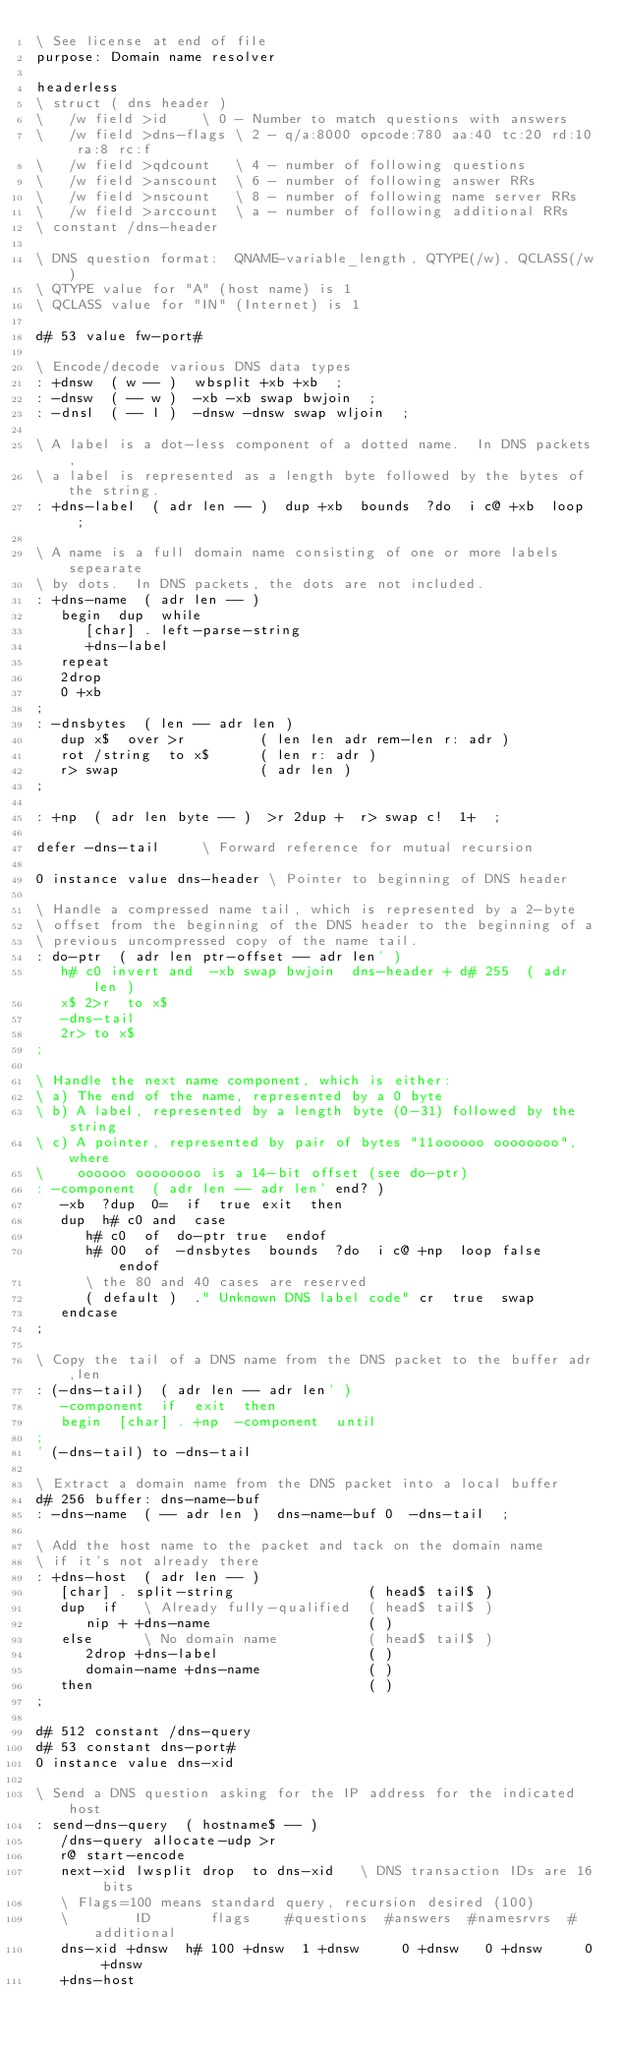Convert code to text. <code><loc_0><loc_0><loc_500><loc_500><_Forth_>\ See license at end of file
purpose: Domain name resolver

headerless
\ struct ( dns header )
\   /w field >id	\ 0 - Number to match questions with answers
\   /w field >dns-flags	\ 2 - q/a:8000 opcode:780 aa:40 tc:20 rd:10 ra:8 rc:f
\   /w field >qdcount	\ 4 - number of following questions
\   /w field >anscount	\ 6 - number of following answer RRs
\   /w field >nscount	\ 8 - number of following name server RRs
\   /w field >arccount	\ a - number of following additional RRs
\ constant /dns-header

\ DNS question format:  QNAME-variable_length, QTYPE(/w), QCLASS(/w)
\ QTYPE value for "A" (host name) is 1
\ QCLASS value for "IN" (Internet) is 1

d# 53 value fw-port#

\ Encode/decode various DNS data types
: +dnsw  ( w -- )  wbsplit +xb +xb  ;
: -dnsw  ( -- w )  -xb -xb swap bwjoin  ;
: -dnsl  ( -- l )  -dnsw -dnsw swap wljoin  ;

\ A label is a dot-less component of a dotted name.  In DNS packets,
\ a label is represented as a length byte followed by the bytes of the string.
: +dns-label  ( adr len -- )  dup +xb  bounds  ?do  i c@ +xb  loop  ;

\ A name is a full domain name consisting of one or more labels sepearate
\ by dots.  In DNS packets, the dots are not included.
: +dns-name  ( adr len -- )
   begin  dup  while
      [char] . left-parse-string
      +dns-label
   repeat
   2drop
   0 +xb
;
: -dnsbytes  ( len -- adr len )
   dup x$  over >r         ( len len adr rem-len r: adr )
   rot /string  to x$      ( len r: adr )
   r> swap                 ( adr len )
;

: +np  ( adr len byte -- )  >r 2dup +  r> swap c!  1+  ;

defer -dns-tail		\ Forward reference for mutual recursion

0 instance value dns-header	\ Pointer to beginning of DNS header

\ Handle a compressed name tail, which is represented by a 2-byte
\ offset from the beginning of the DNS header to the beginning of a
\ previous uncompressed copy of the name tail.
: do-ptr  ( adr len ptr-offset -- adr len' )
   h# c0 invert and  -xb swap bwjoin  dns-header + d# 255  ( adr len )
   x$ 2>r  to x$
   -dns-tail
   2r> to x$
;

\ Handle the next name component, which is either:
\ a) The end of the name, represented by a 0 byte
\ b) A label, represented by a length byte (0-31) followed by the string
\ c) A pointer, represented by pair of bytes "11oooooo oooooooo", where
\    oooooo oooooooo is a 14-bit offset (see do-ptr)
: -component  ( adr len -- adr len' end? )
   -xb  ?dup  0=  if  true exit  then   
   dup  h# c0 and  case
      h# c0  of  do-ptr true  endof
      h# 00  of  -dnsbytes  bounds  ?do  i c@ +np  loop false  endof
      \ the 80 and 40 cases are reserved
      ( default )  ." Unknown DNS label code" cr  true  swap
   endcase
;

\ Copy the tail of a DNS name from the DNS packet to the buffer adr,len
: (-dns-tail)  ( adr len -- adr len' )
   -component  if  exit  then
   begin  [char] . +np  -component  until
;
' (-dns-tail) to -dns-tail

\ Extract a domain name from the DNS packet into a local buffer
d# 256 buffer: dns-name-buf
: -dns-name  ( -- adr len )  dns-name-buf 0  -dns-tail  ;

\ Add the host name to the packet and tack on the domain name
\ if it's not already there
: +dns-host  ( adr len -- )
   [char] . split-string                ( head$ tail$ )
   dup  if   \ Already fully-qualified  ( head$ tail$ )  
      nip + +dns-name                   ( )
   else      \ No domain name           ( head$ tail$ )
      2drop +dns-label                  ( )
      domain-name +dns-name             ( )
   then                                 ( )
;

d# 512 constant /dns-query
d# 53 constant dns-port#
0 instance value dns-xid

\ Send a DNS question asking for the IP address for the indicated host
: send-dns-query  ( hostname$ -- )
   /dns-query allocate-udp >r
   r@ start-encode
   next-xid lwsplit drop  to dns-xid   \ DNS transaction IDs are 16 bits
   \ Flags=100 means standard query, recursion desired (100)
   \        ID       flags    #questions  #answers  #namesrvrs  #additional
   dns-xid +dnsw  h# 100 +dnsw  1 +dnsw     0 +dnsw   0 +dnsw     0 +dnsw
   +dns-host</code> 